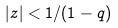<formula> <loc_0><loc_0><loc_500><loc_500>| z | < 1 / ( 1 - q )</formula> 